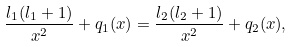<formula> <loc_0><loc_0><loc_500><loc_500>\frac { l _ { 1 } ( l _ { 1 } + 1 ) } { x ^ { 2 } } + q _ { 1 } ( x ) = \frac { l _ { 2 } ( l _ { 2 } + 1 ) } { x ^ { 2 } } + q _ { 2 } ( x ) ,</formula> 